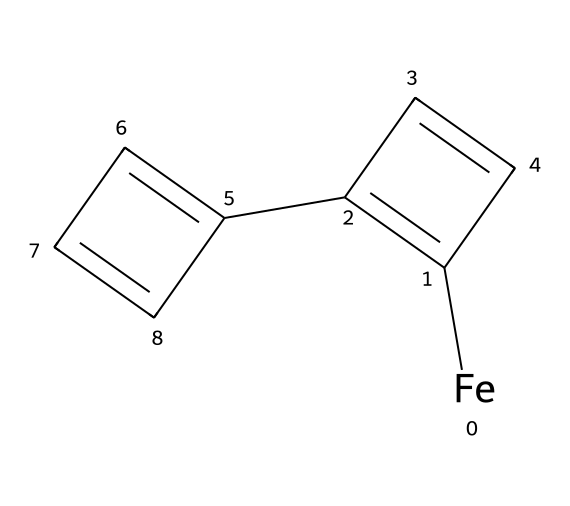What is the metal present in ferrocene? The structure indicates a central metal atom bonded to two cyclopentadienyl rings, which allows us to identify the metal as iron based on common knowledge of ferrocene.
Answer: iron How many carbon atoms are present in the structure of ferrocene? By analyzing the SMILES representation, we count the number of carbon atoms in both cyclopentadienyl rings, totaling ten carbon atoms: five from each ring.
Answer: ten What type of bonding is primarily present in ferrocene? The SMILES shows a classic example of organometallic bonding, specifically the metallocene structure where the metal is sandwiched between π-bonded cyclopentadienyl ligands, indicating significant covalent bonding.
Answer: covalent What is the total number of hydrogen atoms in ferrocene? Counting the hydrogen atoms attached to the carbon atoms in the two cyclopentadienyl rings (each contributing five hydrogens, resulting in a total of ten) leads to the conclusion that there are ten hydrogen atoms.
Answer: ten Why is ferrocene classified as an organometallic compound? The presence of a transition metal (iron) directly bonded to carbon atoms of organic ligands (cyclopentadienyl rings) qualifies it for classification as an organometallic compound, highlighting the interaction between metal and organic species.
Answer: transition metal What is the hybridization state of the iron atom in ferrocene? In ferrocene, the iron atom is surrounded by a planar arrangement of cyclopentadienyl rings, which leads to the conclusion that its hybridization state is typically d2sp3, accommodating the geometry of bonding.
Answer: d2sp3 What is the molecular shape around the iron atom in ferrocene? The arrangement of the two cyclopentadienyl rings symmetrically around the iron atom results in a sandwich-like structure, which corresponds to a trigonal bipyramidal geometry typical for metallocenes.
Answer: trigonal bipyramidal 